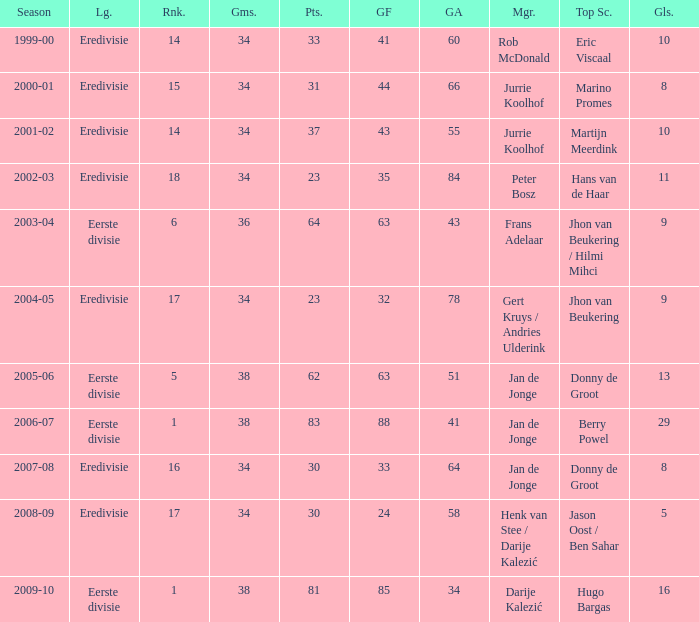Who is the top scorer where gf is 41? Eric Viscaal. 